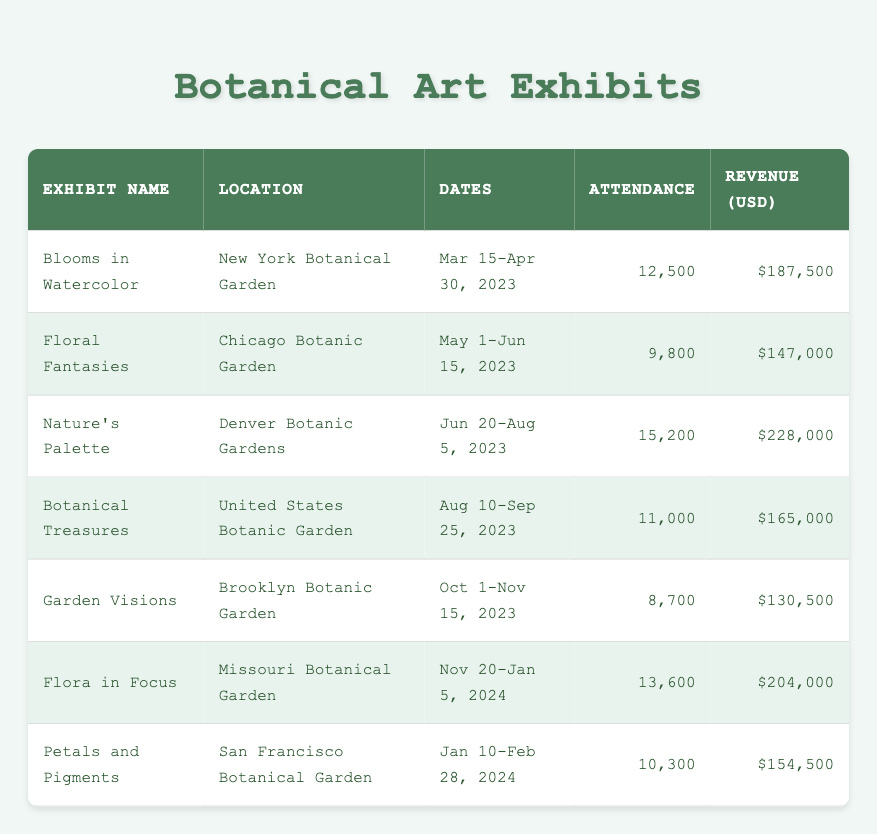What was the attendance for the "Flora in Focus" exhibit? The table shows that "Flora in Focus" had an attendance of 13,600.
Answer: 13,600 Which exhibit had the highest revenue? According to the table, "Nature's Palette" had the highest revenue of $228,000.
Answer: $228,000 What is the total attendance for all exhibits? Summing the attendance values (12,500 + 9,800 + 15,200 + 11,000 + 8,700 + 13,600 + 10,300) gives a total of 91,100 attendees.
Answer: 91,100 Did "Garden Visions" generate more revenue than "Floral Fantasies"? Evaluating the revenue, "Garden Visions" generated $130,500, while "Floral Fantasies" generated $147,000, so the statement is false.
Answer: No What is the average attendance of all exhibits? To find the average, total the attendance (91,100) and divide by the number of exhibits (7), resulting in an average of approximately 13,000 attendees.
Answer: 13,000 Was the attendance for "Botanical Treasures" less than the attendance for "Nature's Palette"? The table shows "Botanical Treasures" had 11,000 attendees and "Nature's Palette" had 15,200 attendees, thus the answer is yes.
Answer: Yes How much revenue did the "San Francisco Botanical Garden" exhibit generate? The revenue for the "Petals and Pigments" exhibit at the "San Francisco Botanical Garden" is $154,500 according to the table.
Answer: $154,500 Which exhibit had the least attendance and what was it? "Garden Visions" had the least attendance at 8,700, as confirmed by the attendance figures in the table.
Answer: 8,700 What was the difference in revenue between "Blooms in Watercolor" and "Botanical Treasures"? The revenue for "Blooms in Watercolor" is $187,500 and for "Botanical Treasures" is $165,000. The difference is $187,500 - $165,000 = $22,500.
Answer: $22,500 